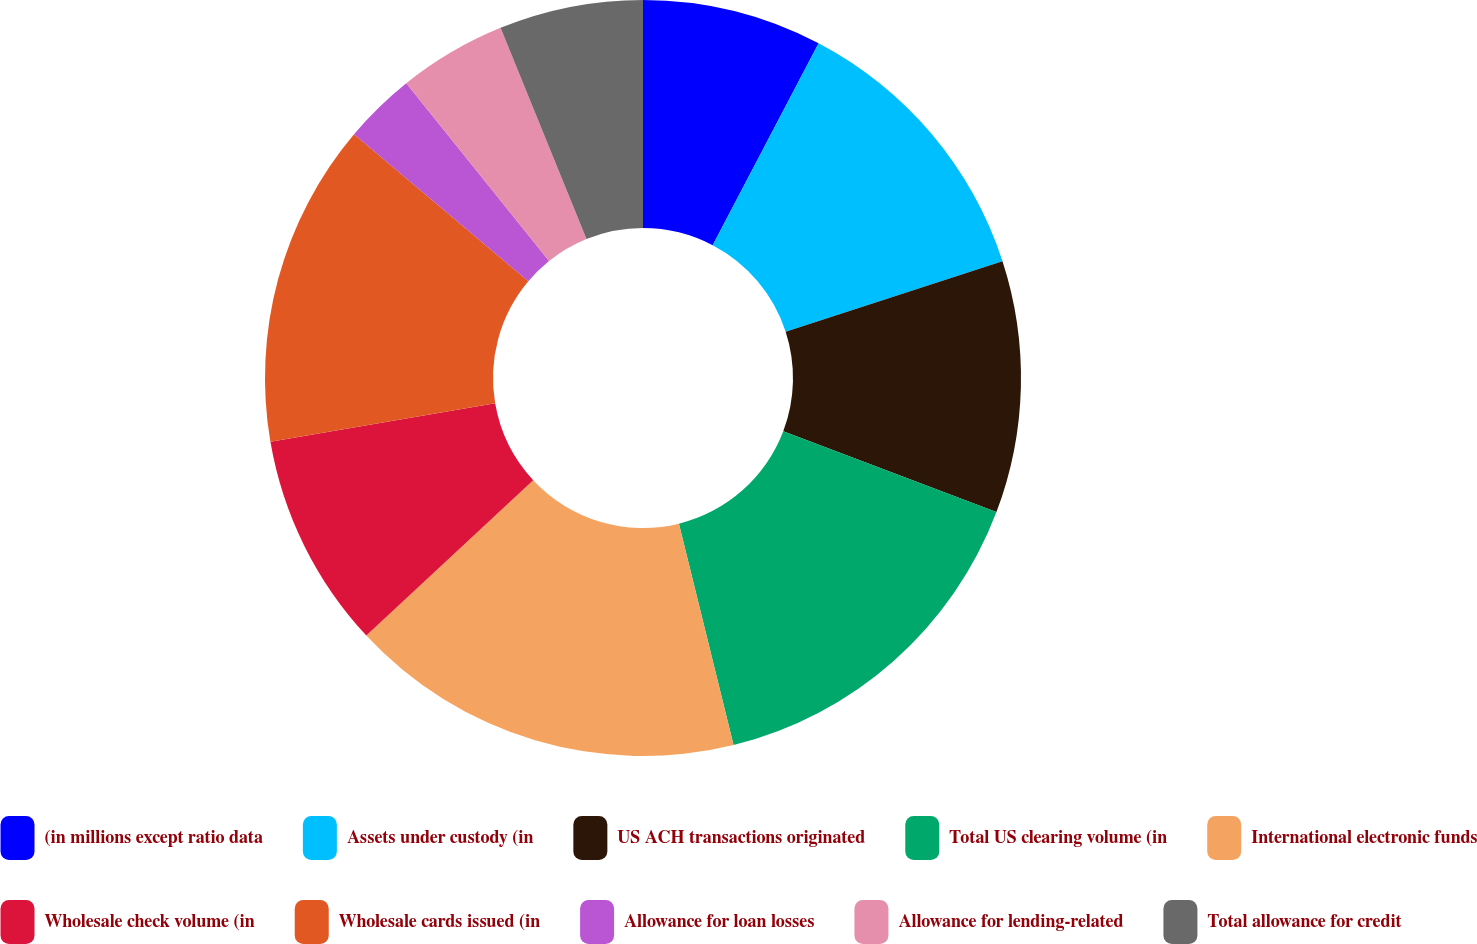Convert chart to OTSL. <chart><loc_0><loc_0><loc_500><loc_500><pie_chart><fcel>(in millions except ratio data<fcel>Assets under custody (in<fcel>US ACH transactions originated<fcel>Total US clearing volume (in<fcel>International electronic funds<fcel>Wholesale check volume (in<fcel>Wholesale cards issued (in<fcel>Allowance for loan losses<fcel>Allowance for lending-related<fcel>Total allowance for credit<nl><fcel>7.69%<fcel>12.31%<fcel>10.77%<fcel>15.38%<fcel>16.92%<fcel>9.23%<fcel>13.85%<fcel>3.08%<fcel>4.62%<fcel>6.15%<nl></chart> 